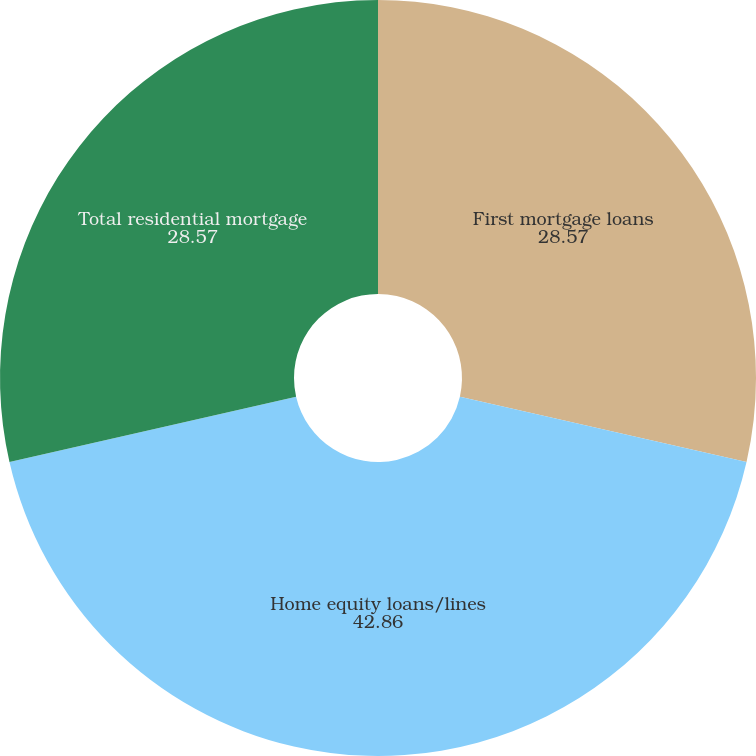<chart> <loc_0><loc_0><loc_500><loc_500><pie_chart><fcel>First mortgage loans<fcel>Home equity loans/lines<fcel>Total residential mortgage<nl><fcel>28.57%<fcel>42.86%<fcel>28.57%<nl></chart> 